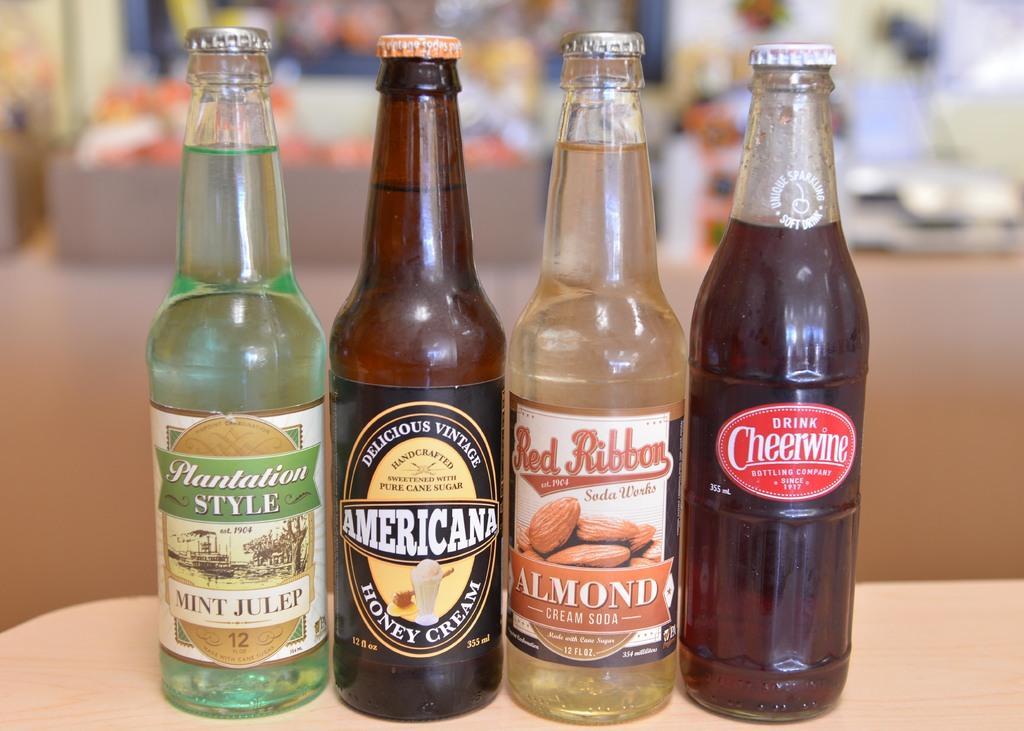Can you describe this image briefly? These 4 bottles are highlighted in this picture. These 4 bottles are filled with liquids. On this bottle there is a picture of almonds. 